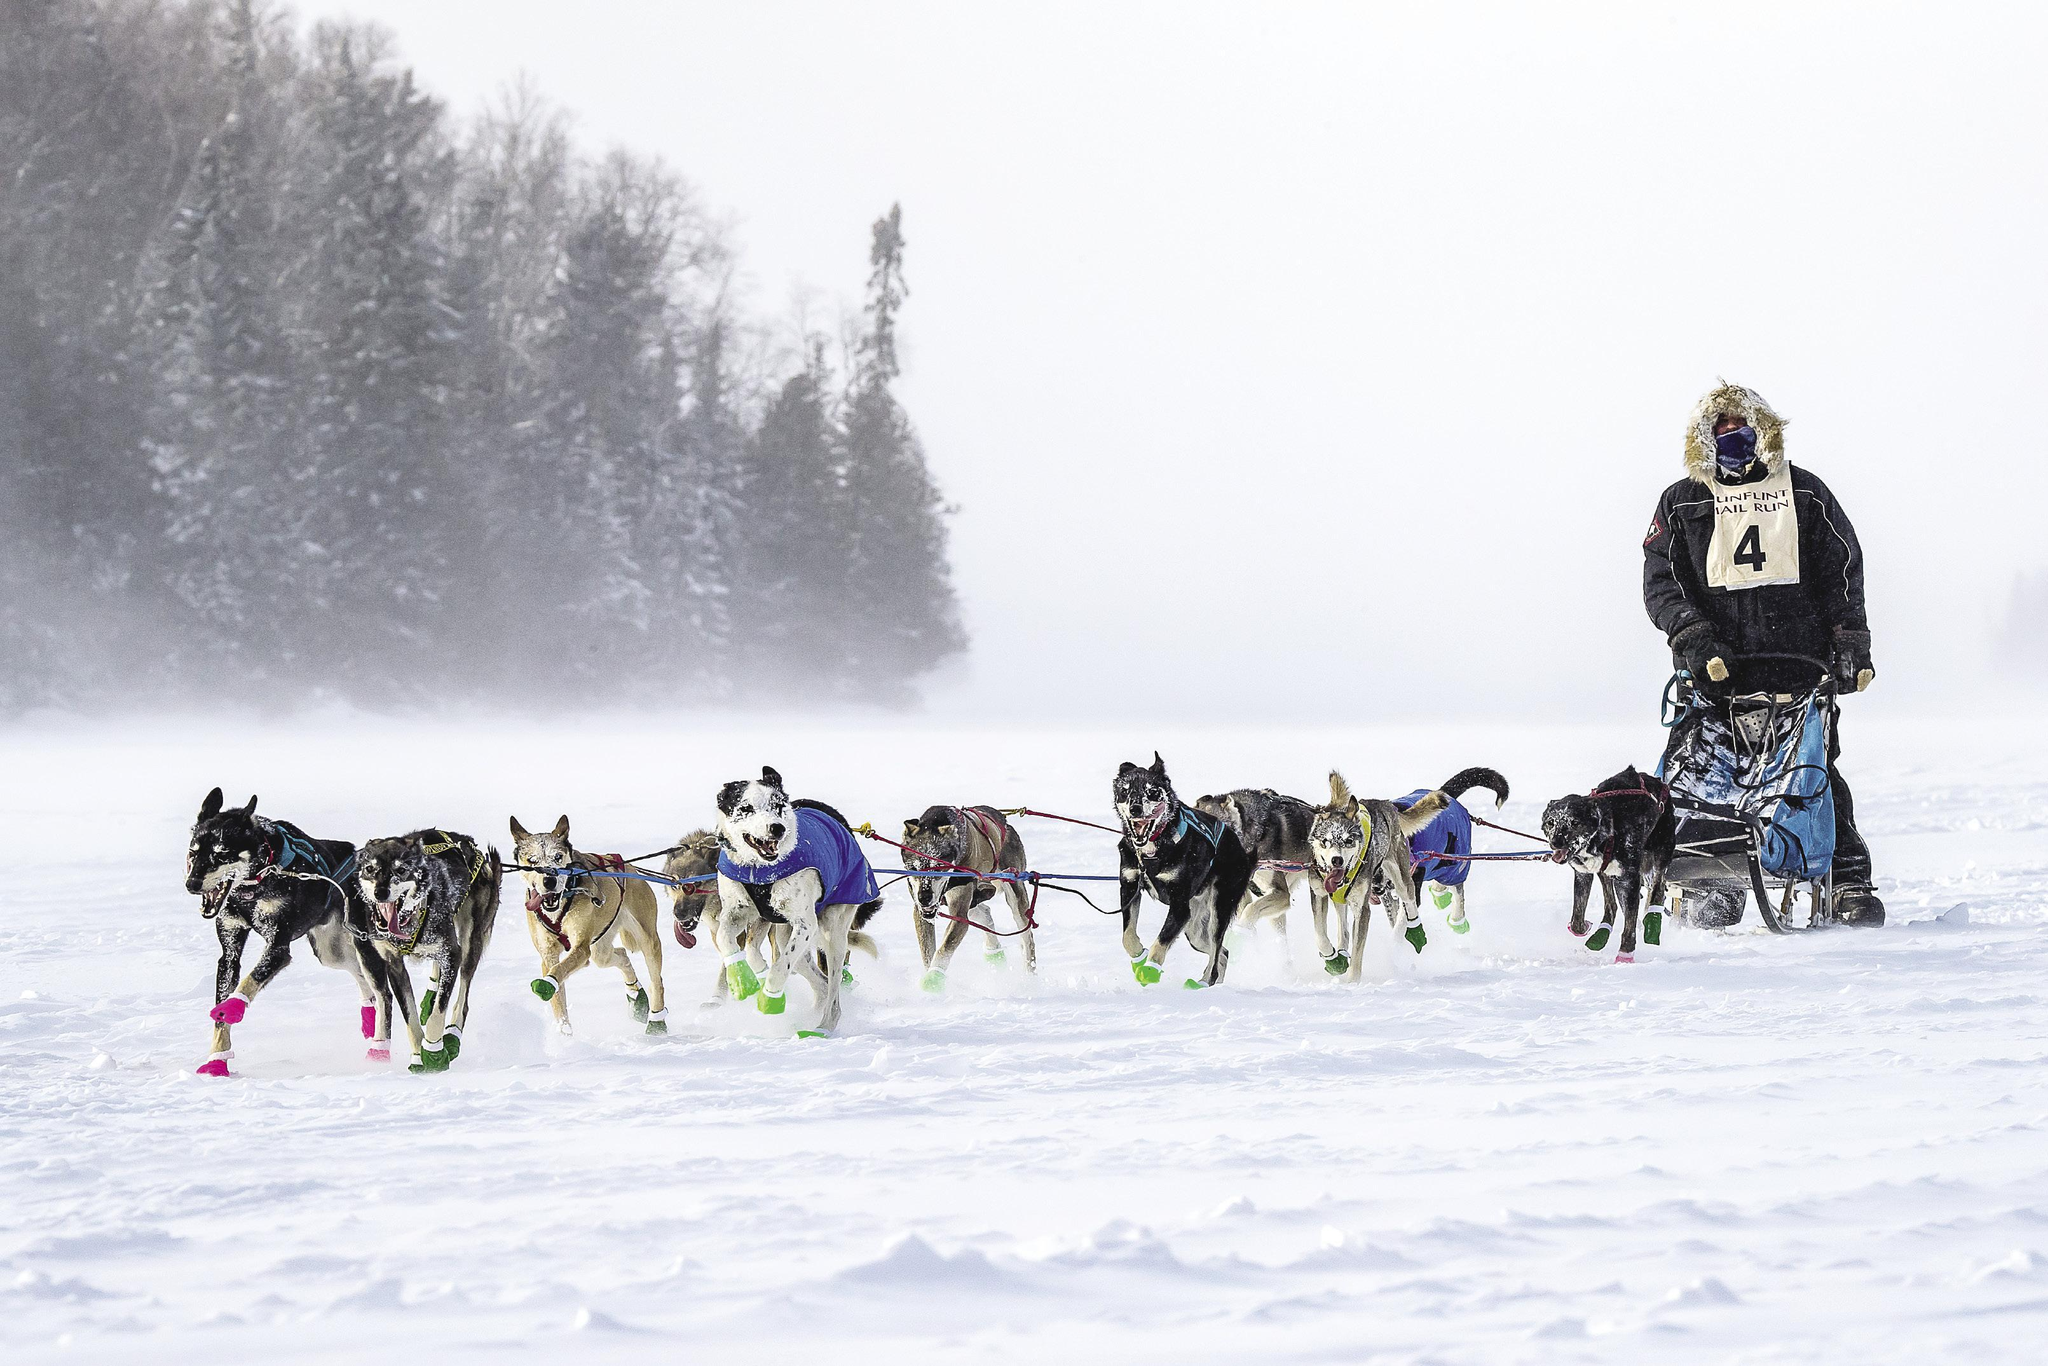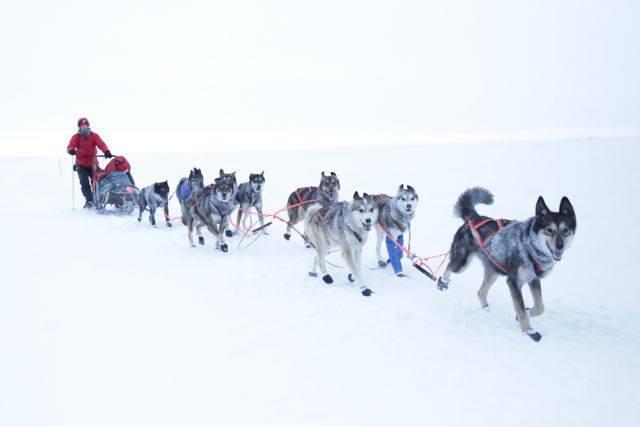The first image is the image on the left, the second image is the image on the right. Given the left and right images, does the statement "The teams of dogs in the left and right images are headed in the same direction." hold true? Answer yes or no. No. 